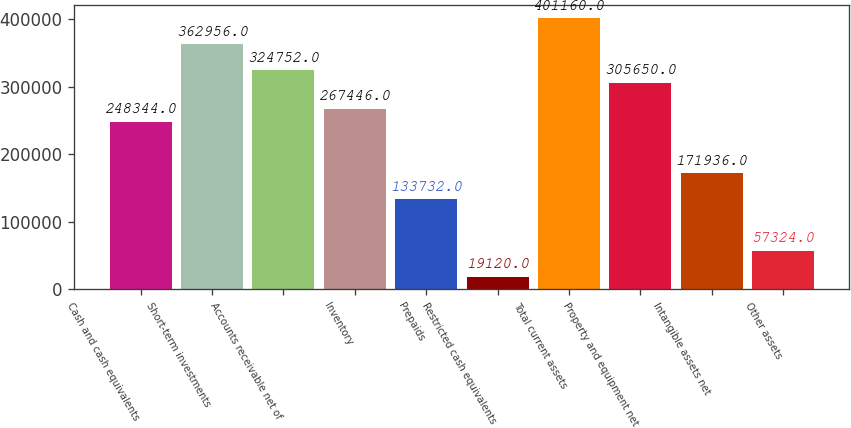<chart> <loc_0><loc_0><loc_500><loc_500><bar_chart><fcel>Cash and cash equivalents<fcel>Short-term investments<fcel>Accounts receivable net of<fcel>Inventory<fcel>Prepaids<fcel>Restricted cash equivalents<fcel>Total current assets<fcel>Property and equipment net<fcel>Intangible assets net<fcel>Other assets<nl><fcel>248344<fcel>362956<fcel>324752<fcel>267446<fcel>133732<fcel>19120<fcel>401160<fcel>305650<fcel>171936<fcel>57324<nl></chart> 